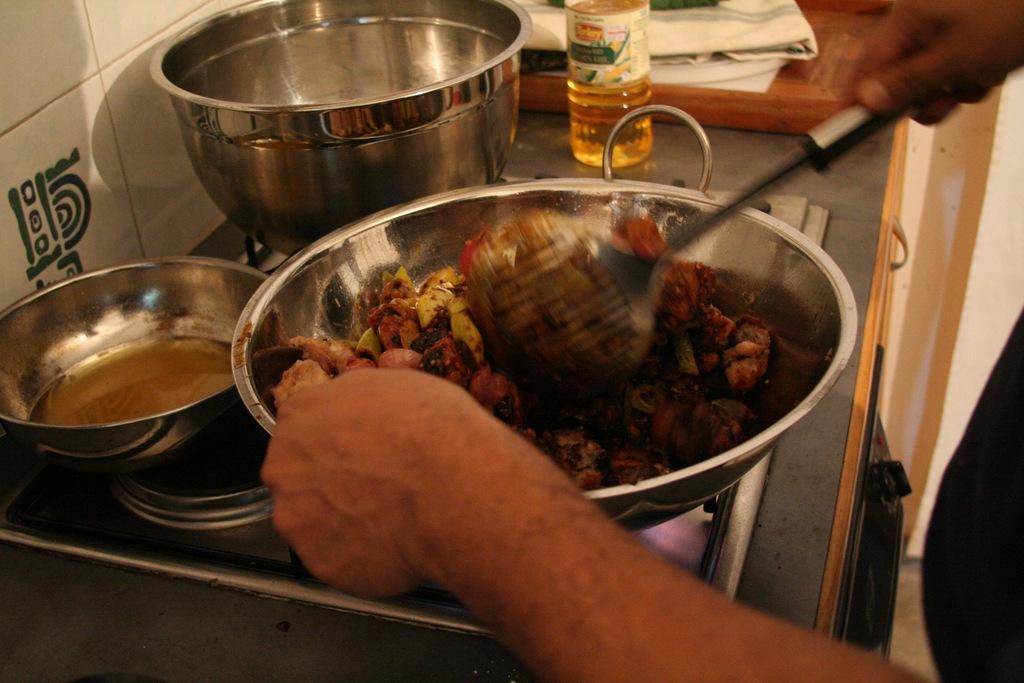Can you describe this image briefly? In this image I can see few vessels on the stove. The person is holding the bowl and the spoon and I can see the food in the bowl. In the background I can see the bottle, cloth and the wall. 